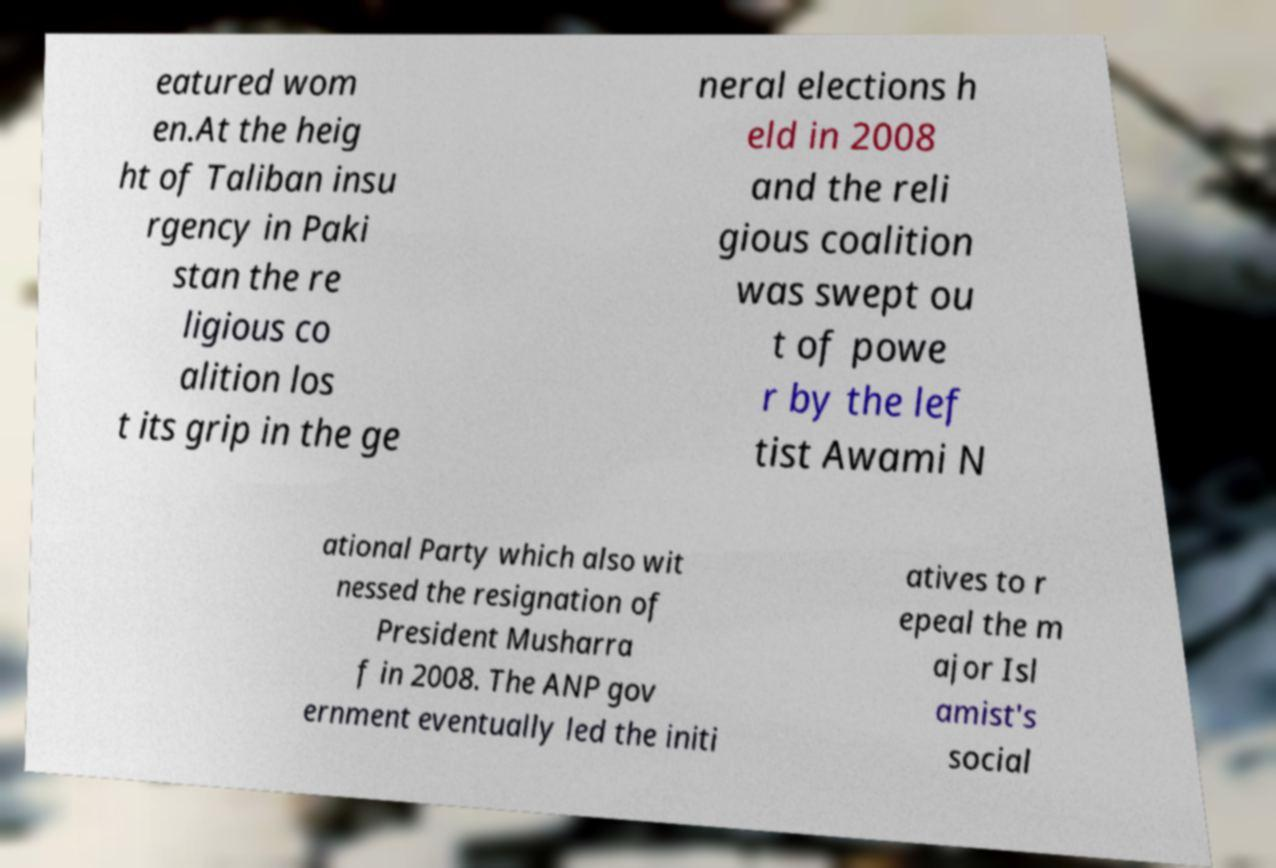Please read and relay the text visible in this image. What does it say? eatured wom en.At the heig ht of Taliban insu rgency in Paki stan the re ligious co alition los t its grip in the ge neral elections h eld in 2008 and the reli gious coalition was swept ou t of powe r by the lef tist Awami N ational Party which also wit nessed the resignation of President Musharra f in 2008. The ANP gov ernment eventually led the initi atives to r epeal the m ajor Isl amist's social 